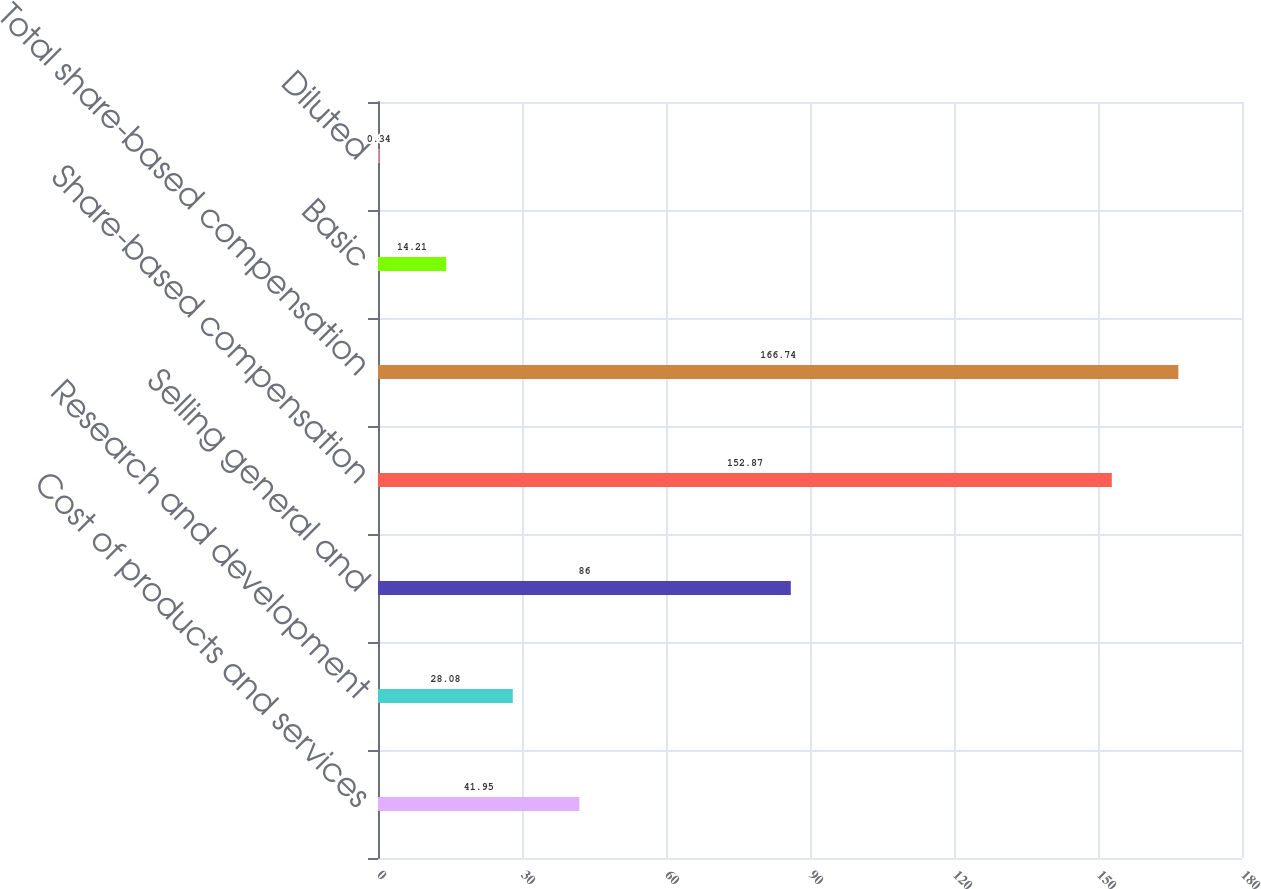Convert chart to OTSL. <chart><loc_0><loc_0><loc_500><loc_500><bar_chart><fcel>Cost of products and services<fcel>Research and development<fcel>Selling general and<fcel>Share-based compensation<fcel>Total share-based compensation<fcel>Basic<fcel>Diluted<nl><fcel>41.95<fcel>28.08<fcel>86<fcel>152.87<fcel>166.74<fcel>14.21<fcel>0.34<nl></chart> 